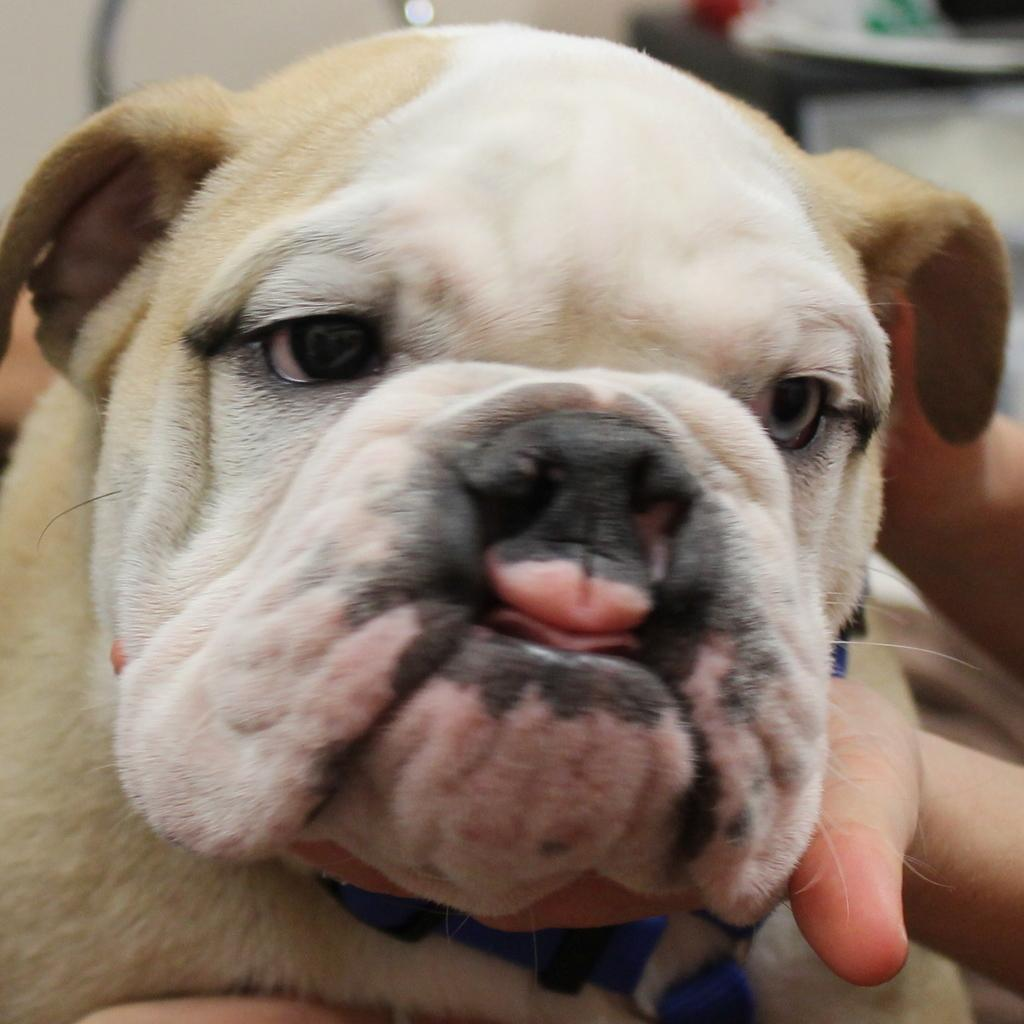Who or what is in the image? There is a person in the image. What is the person doing in the image? The person is holding a dog. What can be seen in the background of the image? There is a wall in the background of the image. What else is present in the image besides the person and the dog? There is a stand with objects in the image. What type of chairs are present in the image? There are no chairs present in the image. 